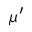<formula> <loc_0><loc_0><loc_500><loc_500>\mu ^ { \prime }</formula> 